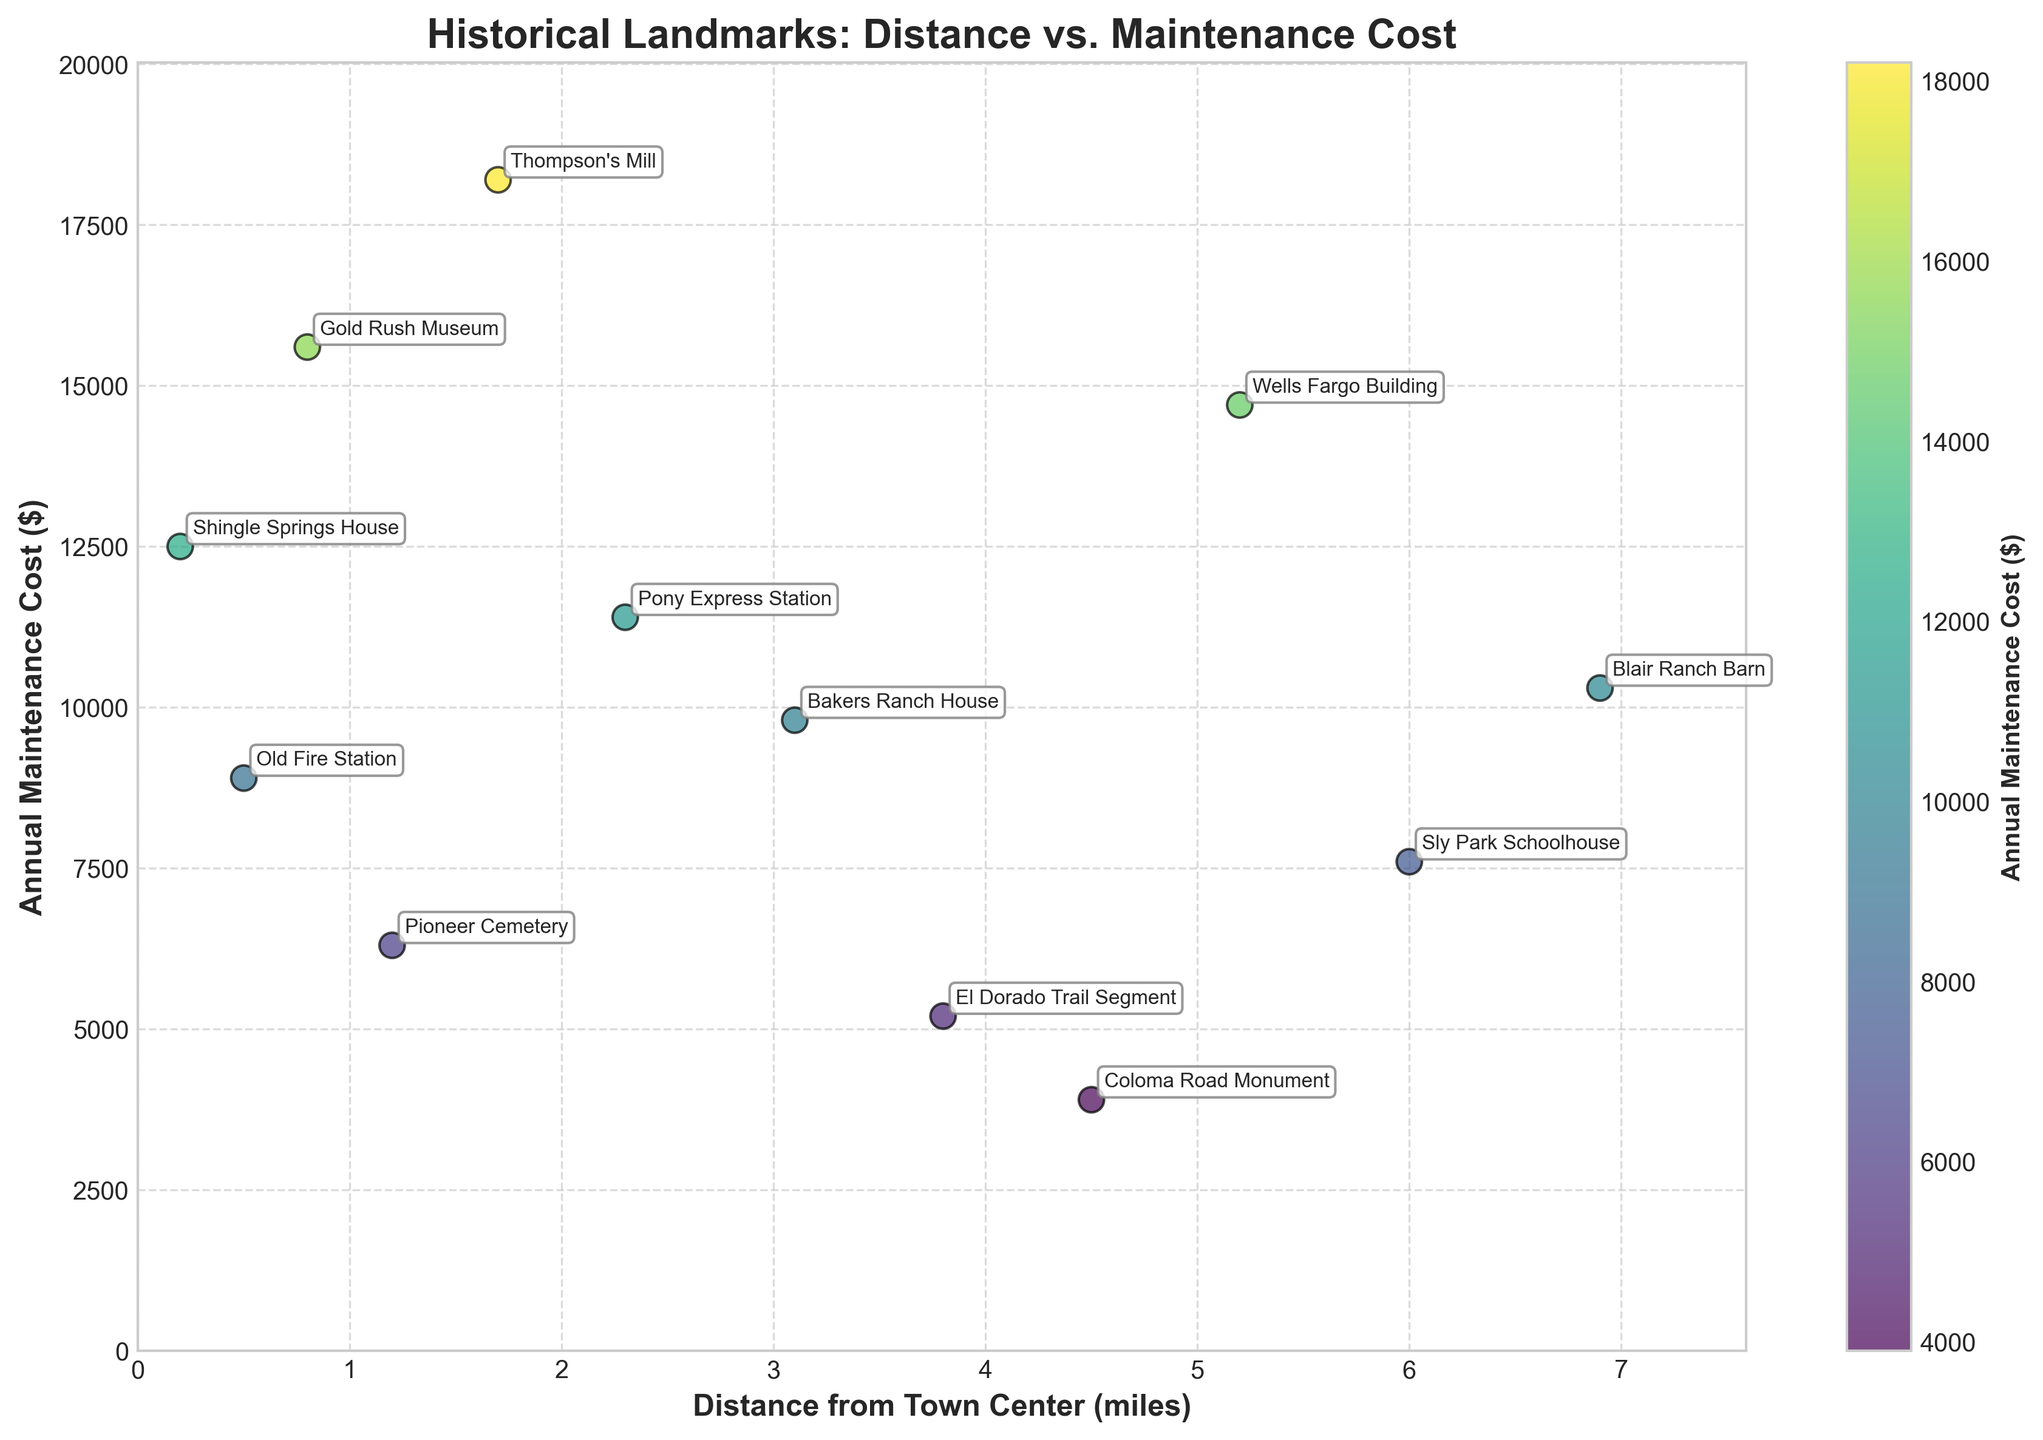What is the title of the figure? The title is usually placed at the top of the figure to provide a summary of what the figure is about. Look for the largest text which is typically bolded.
Answer: Historical Landmarks: Distance vs. Maintenance Cost What are the units on the x-axis? The x-axis units are usually labeled on the axis in parentheses right after the axis description.
Answer: miles What is the landmark farthest from the town center? Identify the highest value on the x-axis and find the corresponding label for that data point.
Answer: Blair Ranch Barn Which landmark has the highest annual maintenance cost? Find the highest value on the y-axis and locate the corresponding label for that data point.
Answer: Thompson's Mill What is the distance from the town center of the Gold Rush Museum? Locate the Gold Rush Museum data point on the scatter plot and read the corresponding x-axis value.
Answer: 0.8 miles How many landmarks have an annual maintenance cost above $10,000? Count how many data points are positioned above the $10,000 mark on the y-axis.
Answer: 6 Which landmark has the lowest annual maintenance cost? Identify the lowest value on the y-axis and find the corresponding label for that data point.
Answer: Coloma Road Monument Is there a visible trend between distance from the town center and annual maintenance cost? Observe whether the data points form a pattern, such as increasing or decreasing as you move along the x-axis.
Answer: No clear trend What is the average annual maintenance cost of landmarks within 2 miles from the town center? Identify the landmarks within 2 miles, sum their maintenance costs and divide by the total number of these landmarks (7 landmarks in total). Total cost: 12500 + 8900 + 15600 + 6300 + 18200 + 11400 + 9800 = 82300. Average cost: 82300 / 7.
Answer: $11,757 Which landmark situated beyond 3 miles has a maintenance cost closest to $10,000? Locate the landmarks beyond 3 miles on the x-axis and identify the one whose y-axis value is nearest to $10,000.
Answer: Blair Ranch Barn 